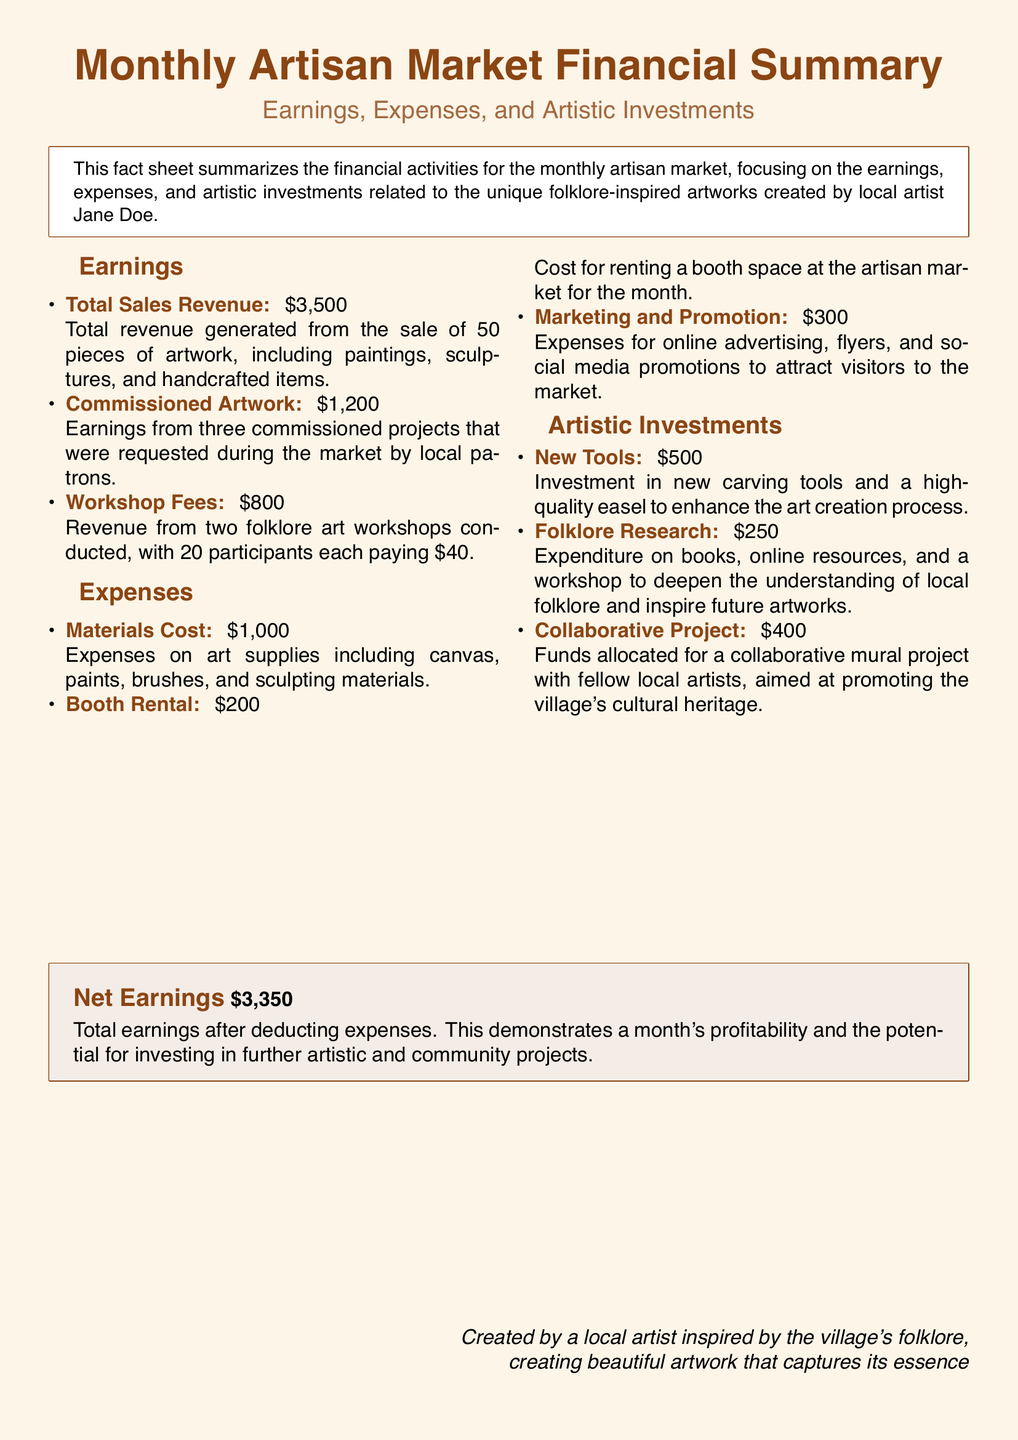What is the total sales revenue? The total sales revenue is stated in the earnings section, which lists it as $3,500.
Answer: $3,500 How much was earned from workshops? The workshop fees indicate total earnings of $800 from two folklore art workshops.
Answer: $800 What is the total amount of expenses? The total expenses include materials cost, booth rental, and marketing which add up to $1,500.
Answer: $1,500 How much was invested in new tools? The artistic investments section specifies that $500 was spent on new tools.
Answer: $500 What is the net earnings amount? The net earnings, after deducting expenses from total earnings, is $3,350, as noted in the document.
Answer: $3,350 What was the booth rental cost? The document lists the booth rental cost specifically as $200.
Answer: $200 How many commissioned projects were there? The earnings from commissioned artwork mention three projects were completed.
Answer: three How many participants were in each workshop? The document states that there were 20 participants in each workshop conducted.
Answer: 20 What is the purpose of the collaborative project? The purpose of the collaborative project is to promote the village's cultural heritage, as indicated in the artistic investments section.
Answer: promote cultural heritage 